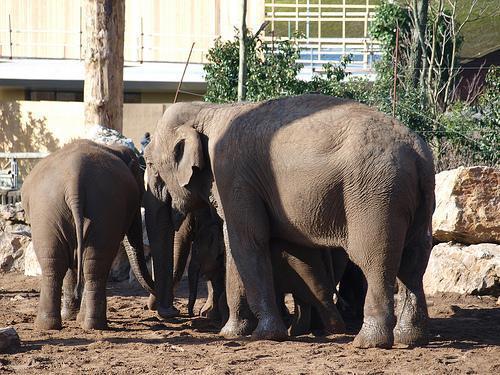How many rocks are to the right of the elephant?
Give a very brief answer. 2. 